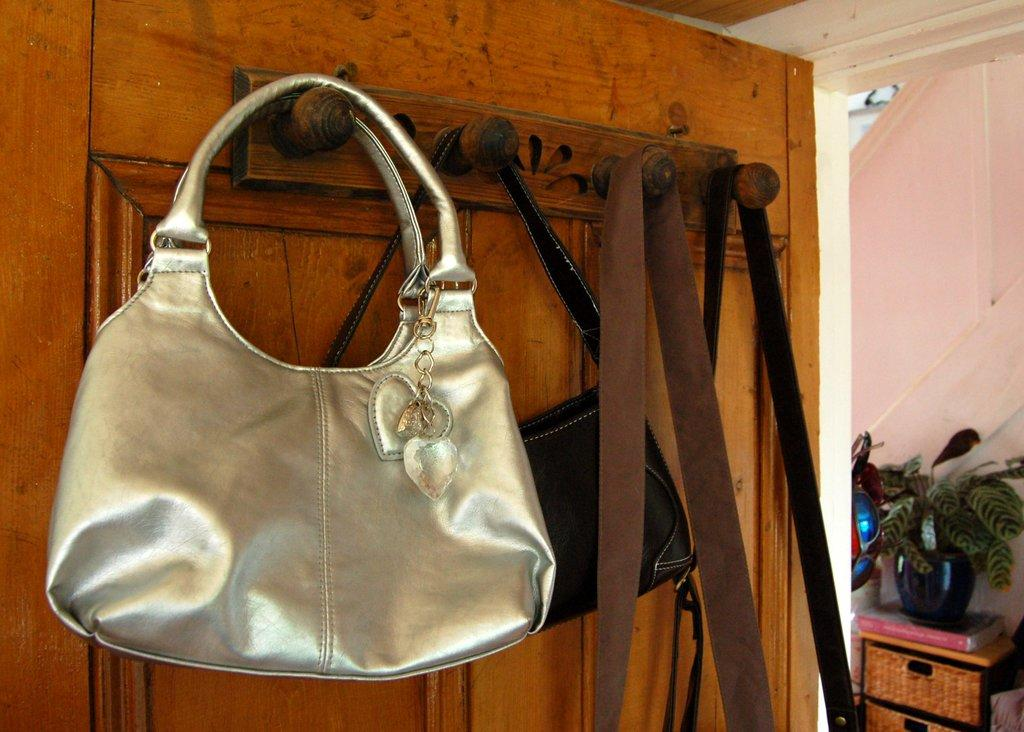What is hanging on the door in the image? There are bags hanging on the door. Can you describe the plant in the image? There is a water plant on the cupboard. Where is the kitten playing with a vest in the image? There is no kitten or vest present in the image. What type of humor can be seen in the image? There is no humor depicted in the image; it simply shows bags hanging on the door and a water plant on the cupboard. 